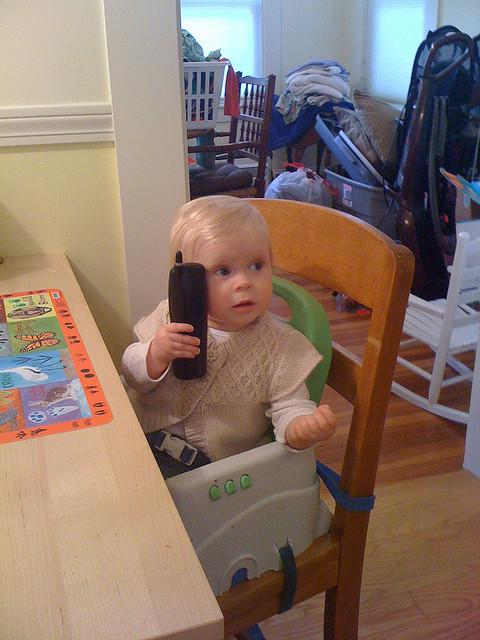Whos number did the child dial? mother 